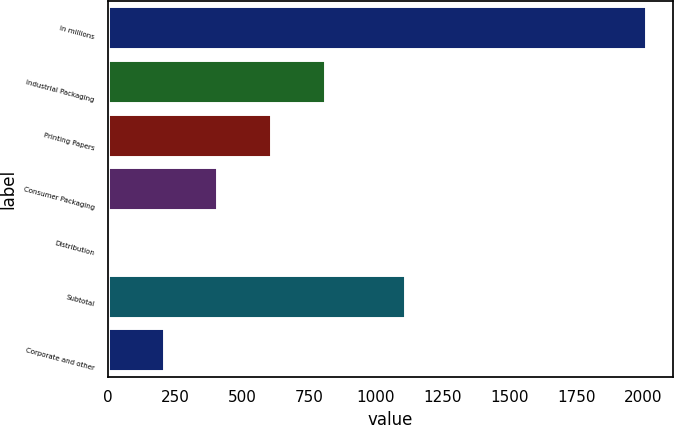<chart> <loc_0><loc_0><loc_500><loc_500><bar_chart><fcel>In millions<fcel>Industrial Packaging<fcel>Printing Papers<fcel>Consumer Packaging<fcel>Distribution<fcel>Subtotal<fcel>Corporate and other<nl><fcel>2011<fcel>809.2<fcel>608.9<fcel>408.6<fcel>8<fcel>1108<fcel>208.3<nl></chart> 